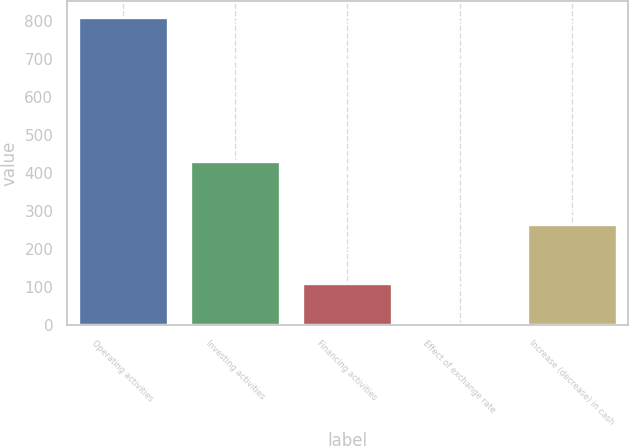Convert chart. <chart><loc_0><loc_0><loc_500><loc_500><bar_chart><fcel>Operating activities<fcel>Investing activities<fcel>Financing activities<fcel>Effect of exchange rate<fcel>Increase (decrease) in cash<nl><fcel>812<fcel>432<fcel>110<fcel>4<fcel>266<nl></chart> 